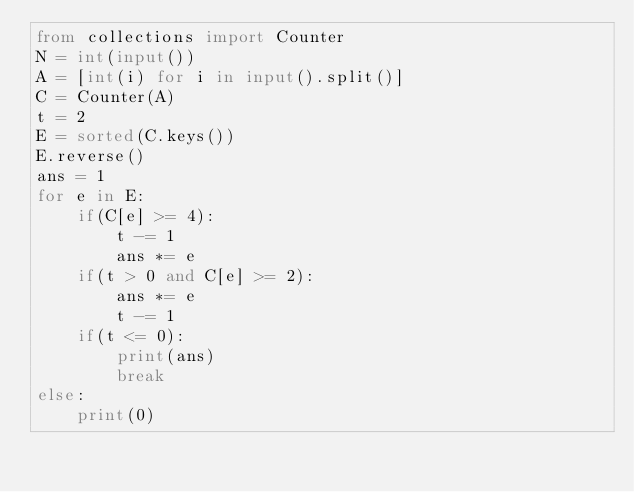<code> <loc_0><loc_0><loc_500><loc_500><_Python_>from collections import Counter
N = int(input())
A = [int(i) for i in input().split()]
C = Counter(A)
t = 2
E = sorted(C.keys())
E.reverse()
ans = 1
for e in E:
    if(C[e] >= 4):
        t -= 1
        ans *= e
    if(t > 0 and C[e] >= 2):
        ans *= e
        t -= 1
    if(t <= 0):
        print(ans)
        break
else:
    print(0)
</code> 